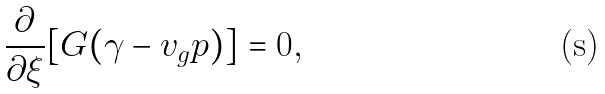<formula> <loc_0><loc_0><loc_500><loc_500>\frac { \partial } { \partial \xi } [ G ( \gamma - v _ { g } p ) ] = 0 ,</formula> 